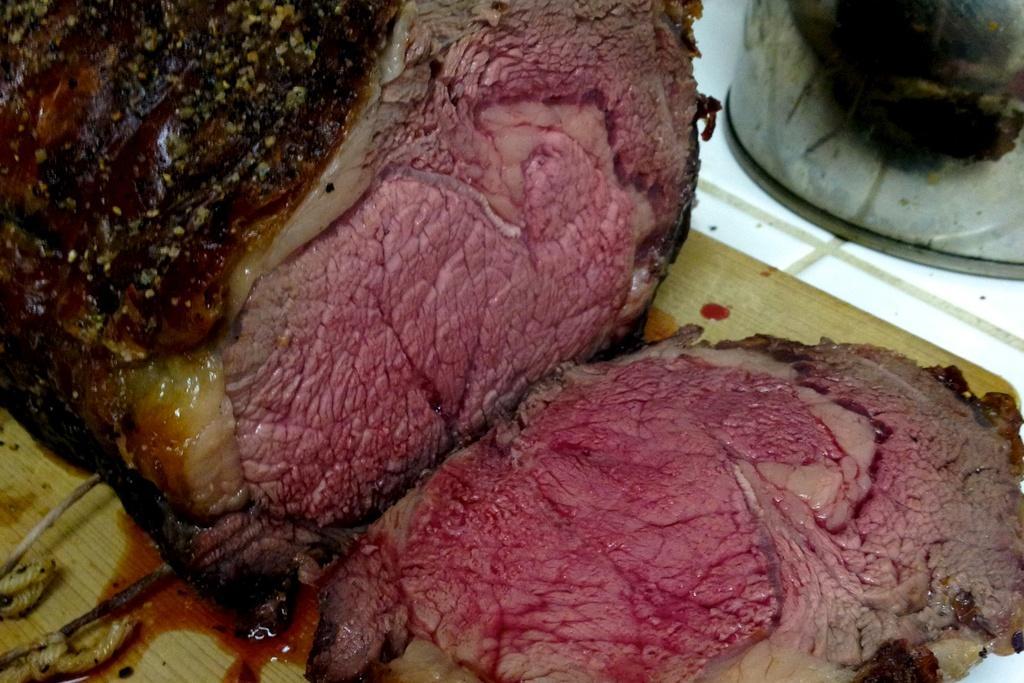How would you summarize this image in a sentence or two? In the foreground of this picture, there is a roast beef on a wooden board. 